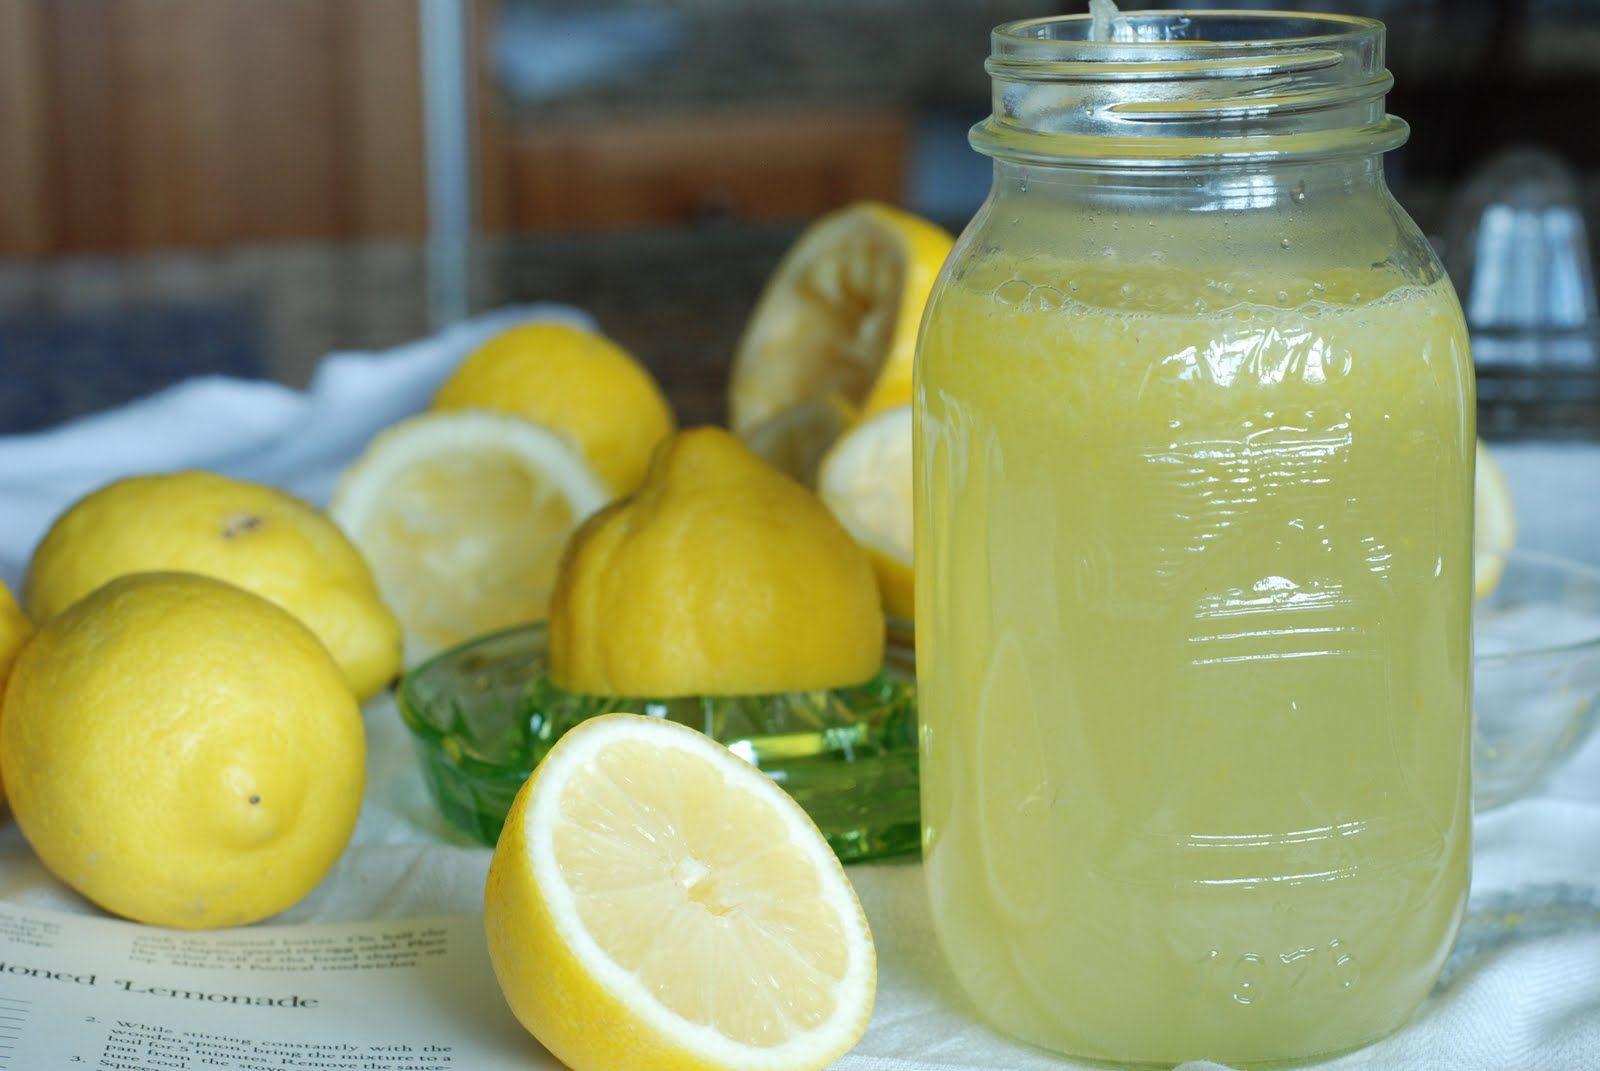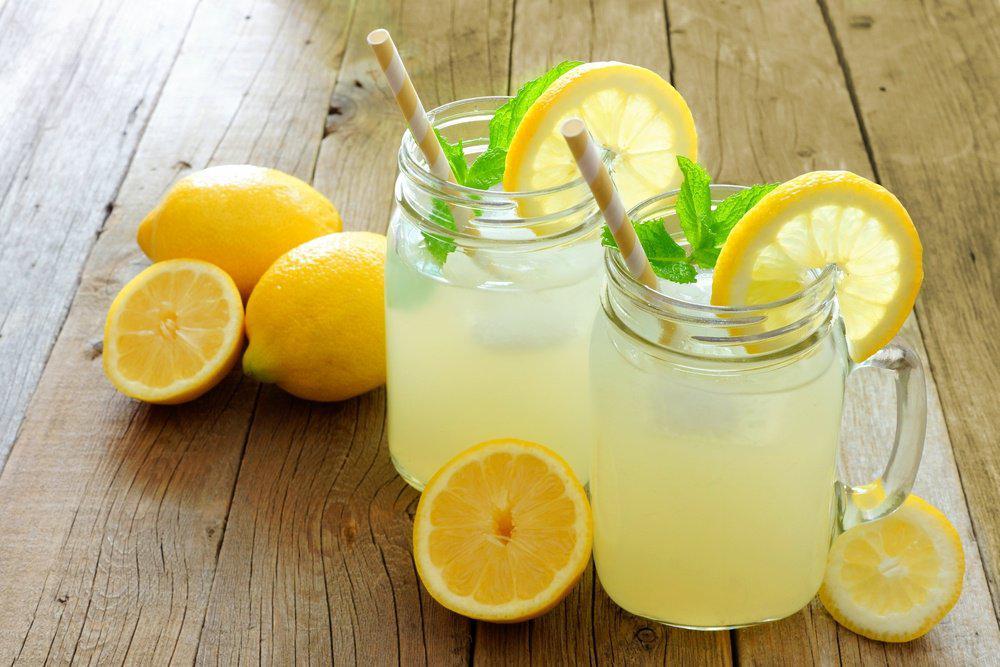The first image is the image on the left, the second image is the image on the right. Considering the images on both sides, is "The left image includes lemons and a beverage in a drinking glass in front of a pitcher, and the right image includes a pitcher with a rounded bottom." valid? Answer yes or no. No. 